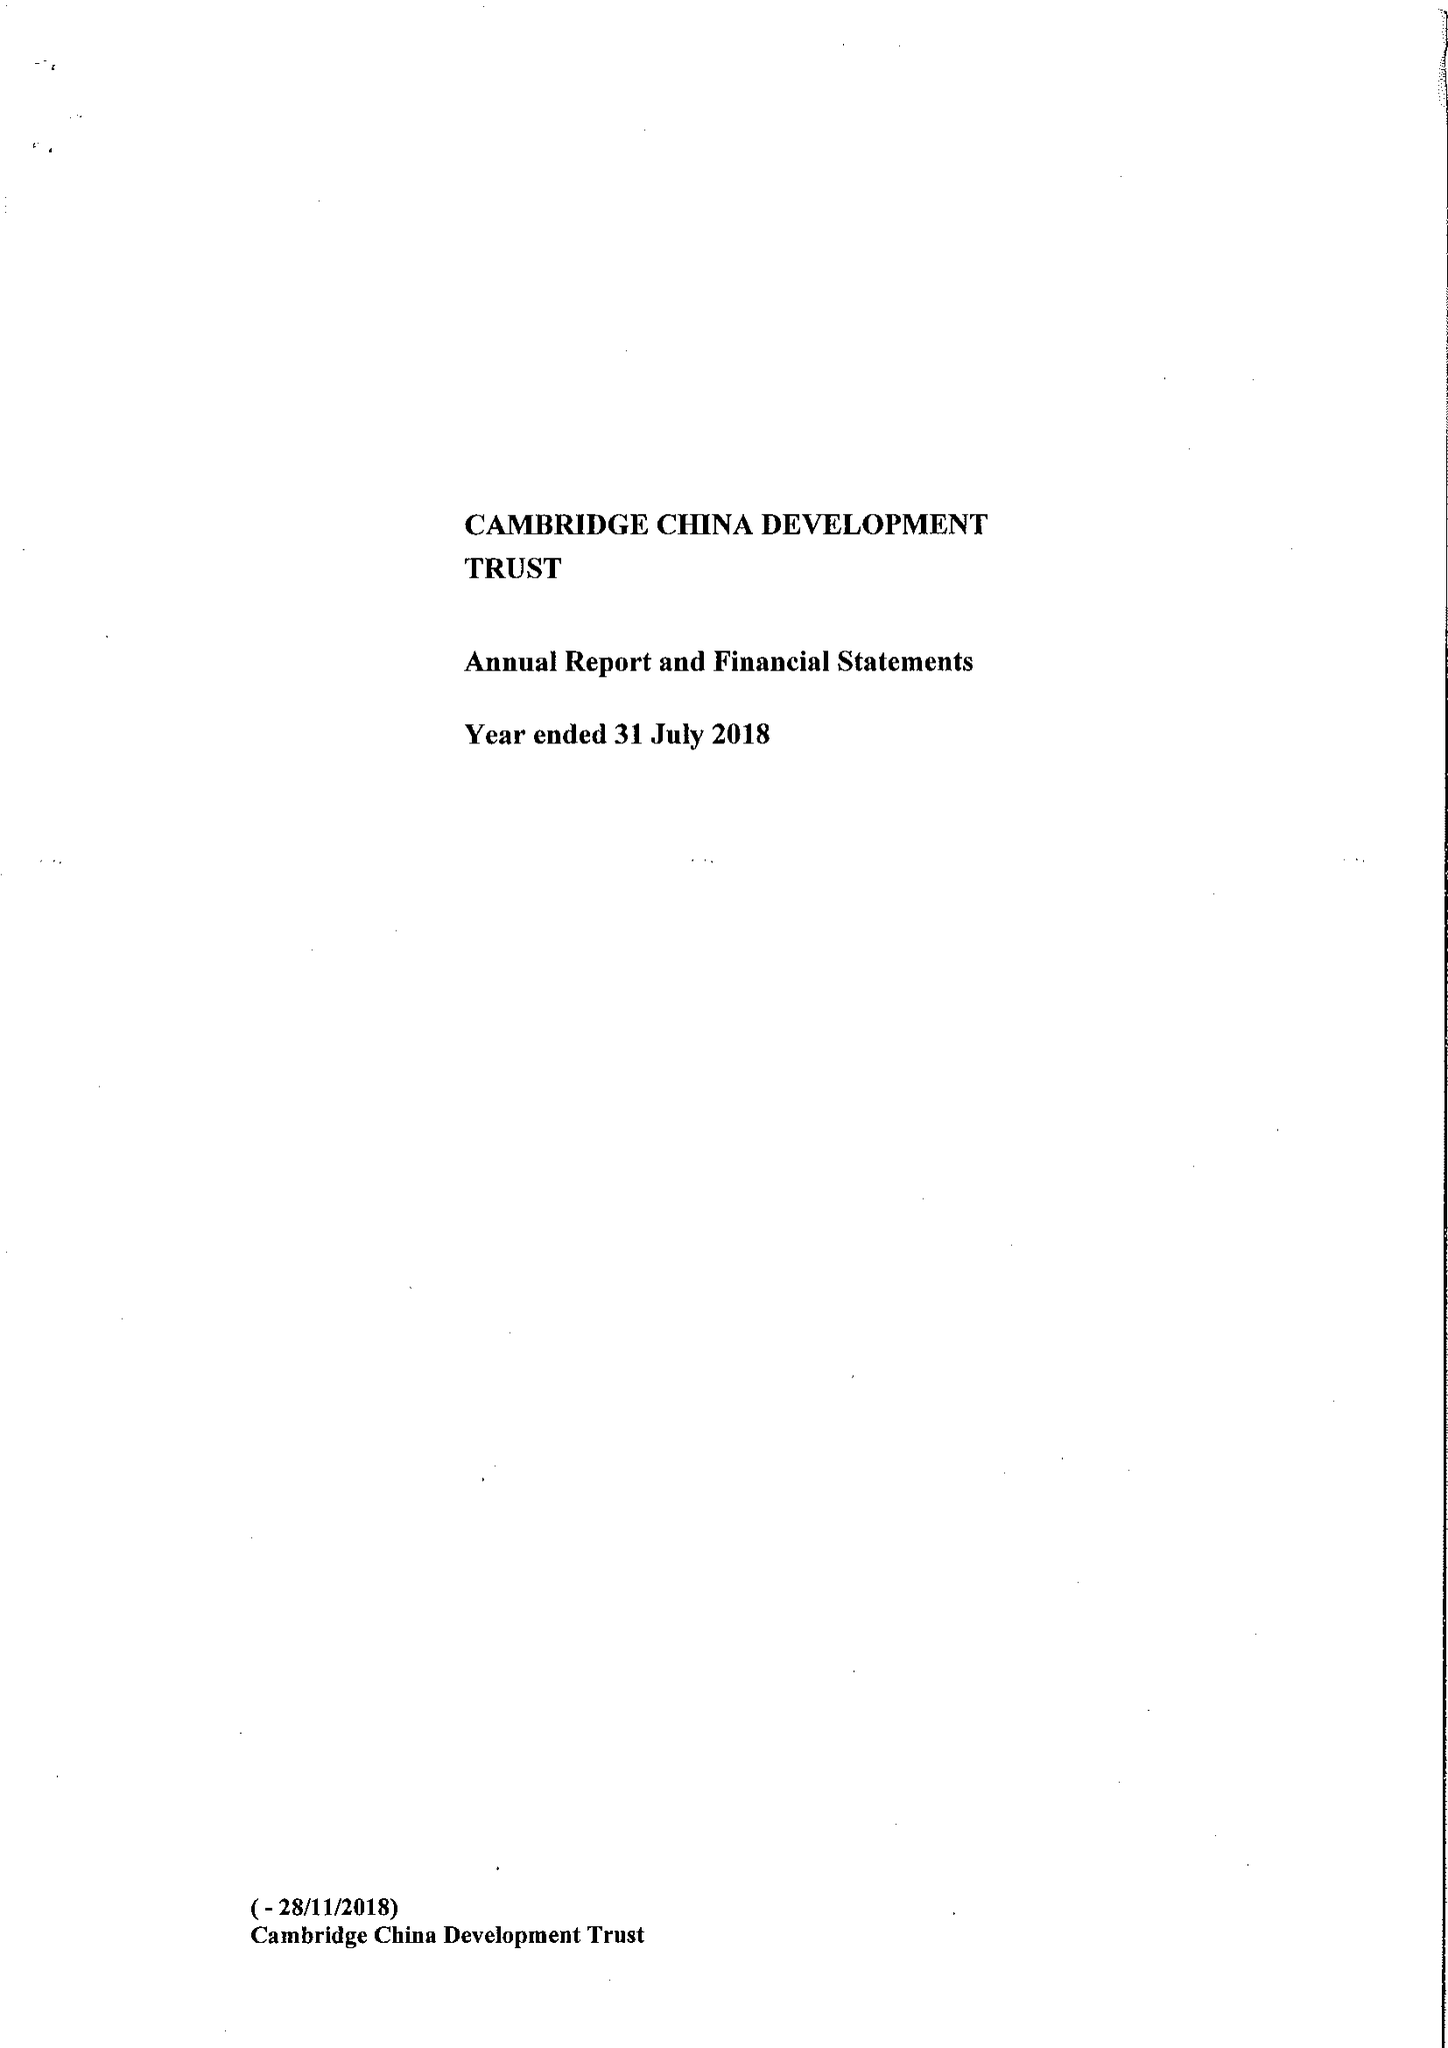What is the value for the charity_name?
Answer the question using a single word or phrase. The Cambridge China Development Trust 